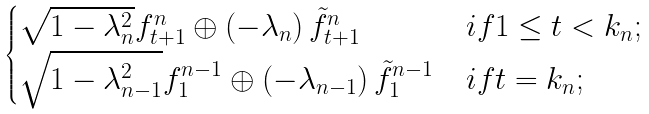<formula> <loc_0><loc_0><loc_500><loc_500>\begin{cases} \sqrt { 1 - \lambda _ { n } ^ { 2 } } f ^ { n } _ { t + 1 } \oplus \left ( - \lambda _ { n } \right ) \tilde { f } ^ { n } _ { t + 1 } & i f 1 \leq t < k _ { n } ; \\ \sqrt { 1 - \lambda _ { n - 1 } ^ { 2 } } f ^ { n - 1 } _ { 1 } \oplus \left ( - \lambda _ { n - 1 } \right ) \tilde { f } ^ { n - 1 } _ { 1 } & i f t = k _ { n } ; \end{cases}</formula> 